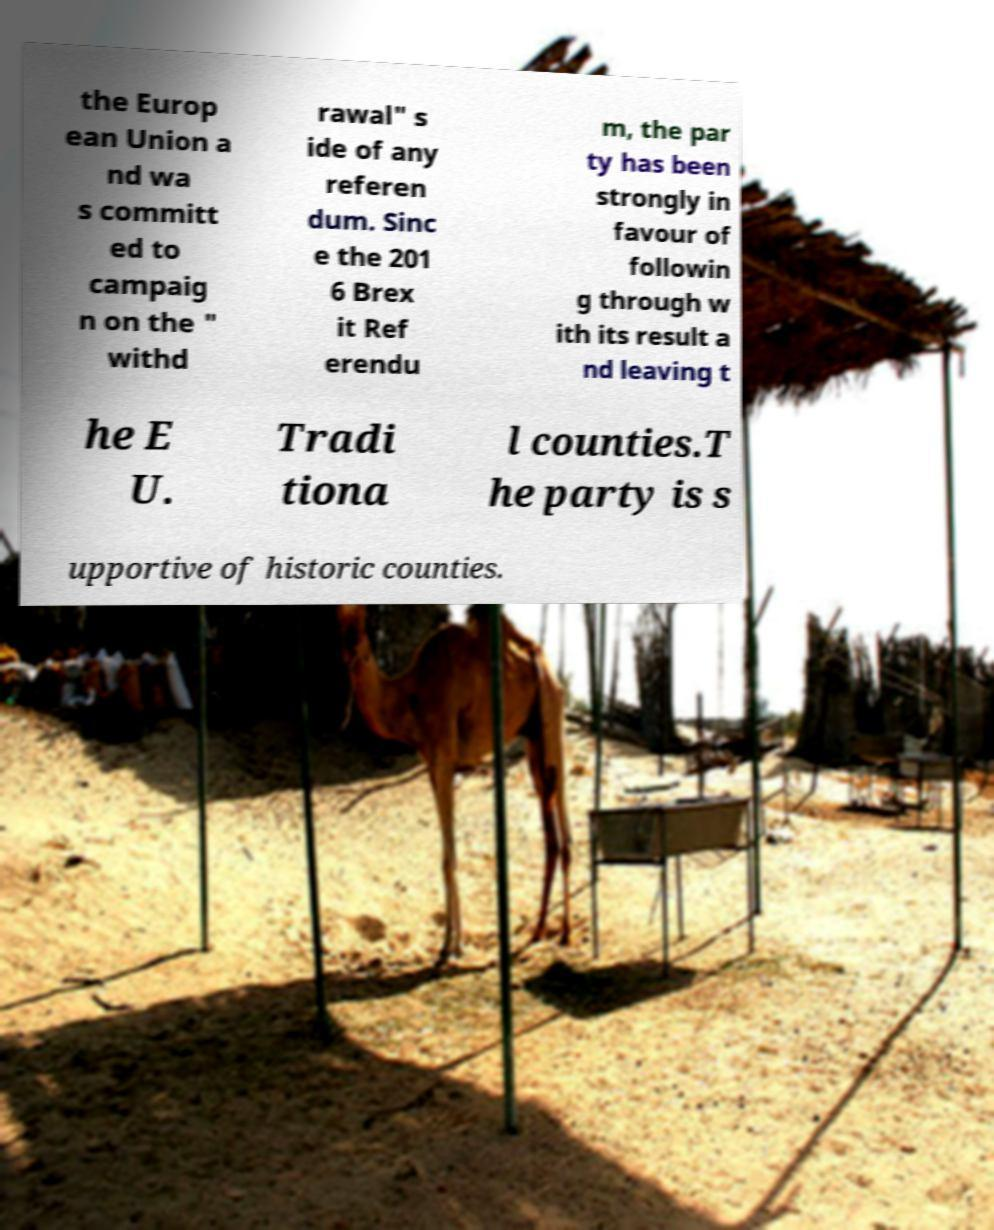There's text embedded in this image that I need extracted. Can you transcribe it verbatim? the Europ ean Union a nd wa s committ ed to campaig n on the " withd rawal" s ide of any referen dum. Sinc e the 201 6 Brex it Ref erendu m, the par ty has been strongly in favour of followin g through w ith its result a nd leaving t he E U. Tradi tiona l counties.T he party is s upportive of historic counties. 